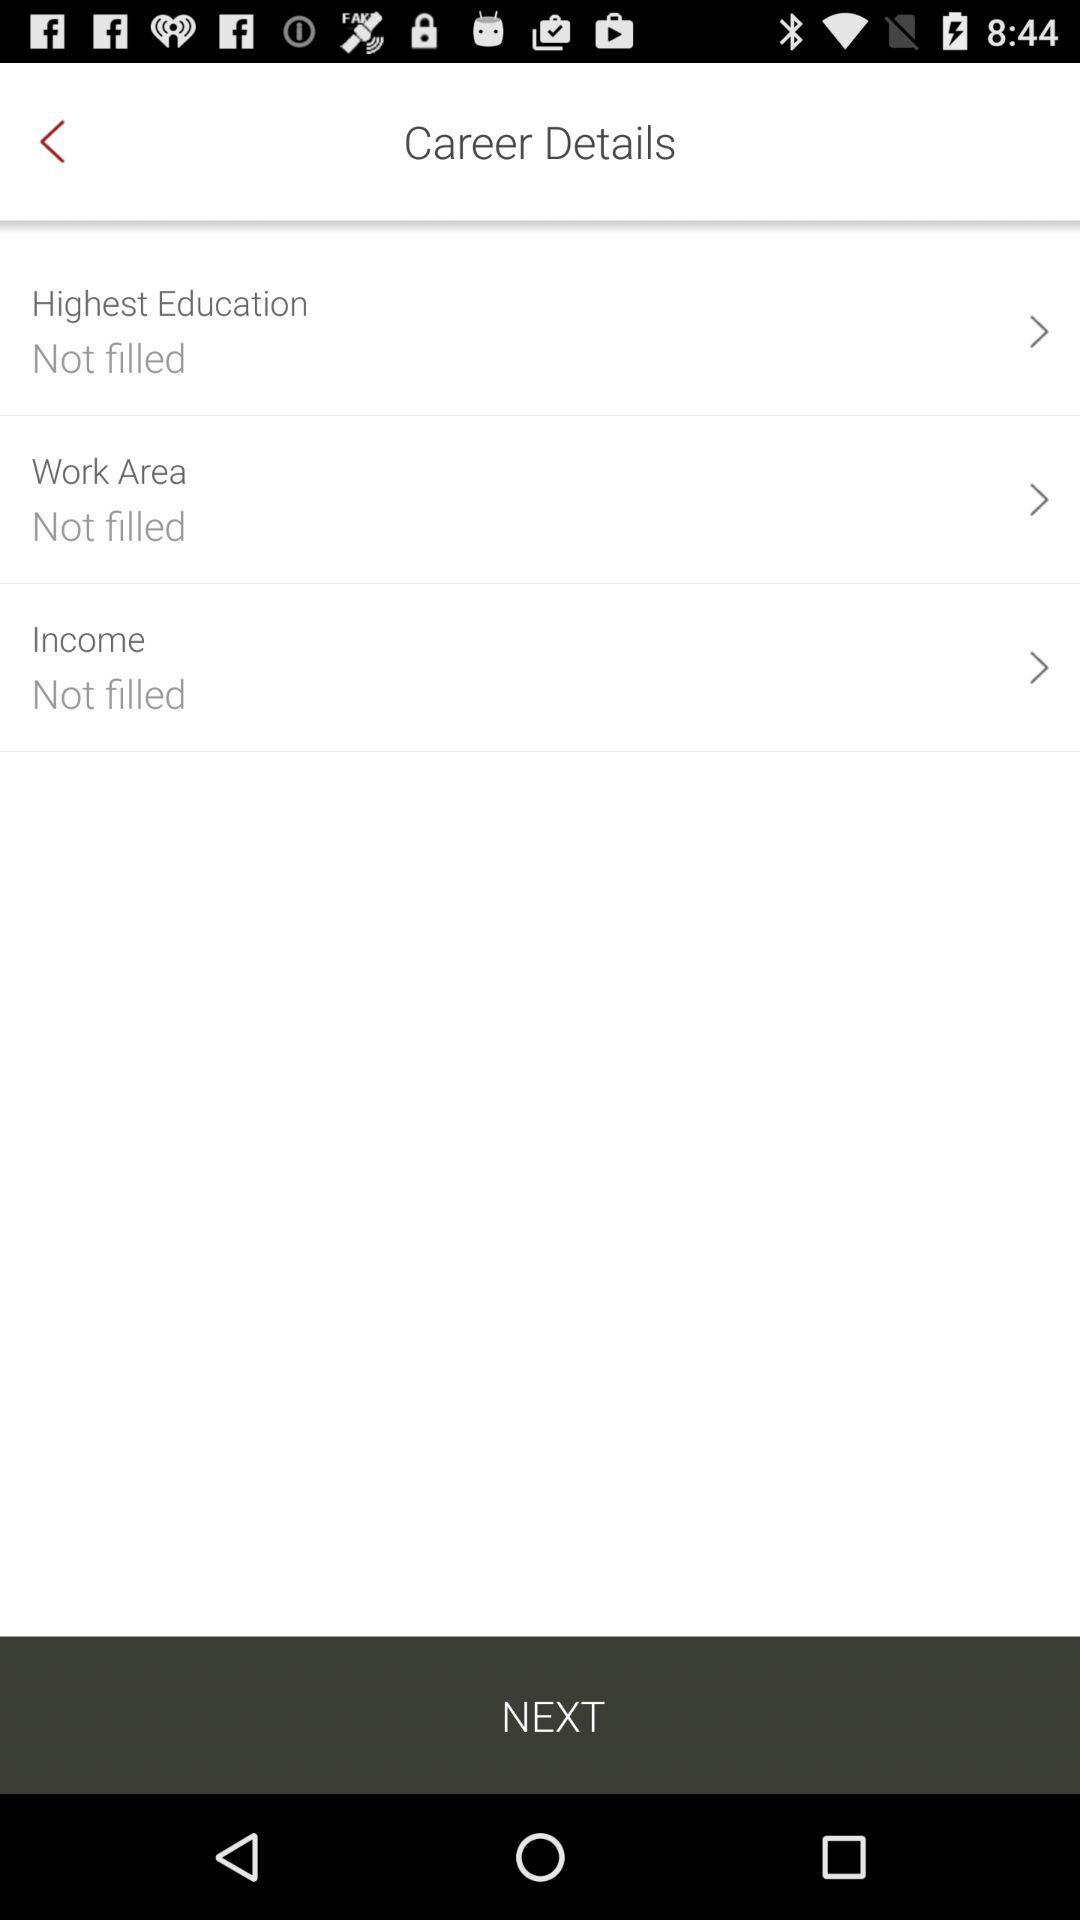How many items have not been filled?
Answer the question using a single word or phrase. 3 